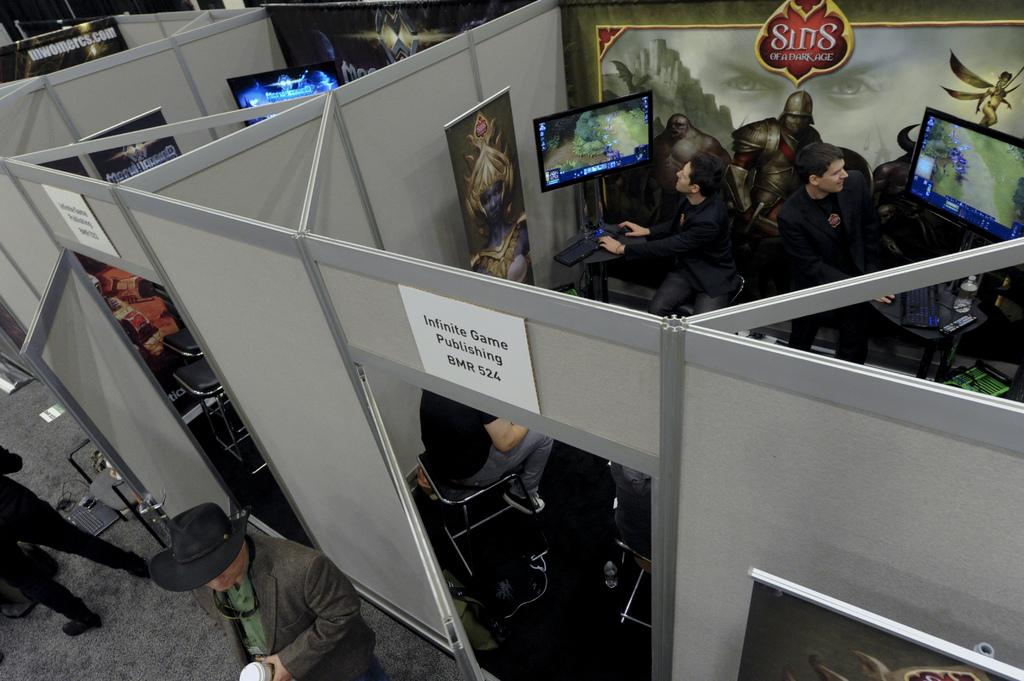<image>
Create a compact narrative representing the image presented. An aerial view of an office that has a sign over the doorway reading Infinite Game Publishing. 